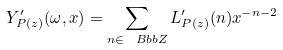<formula> <loc_0><loc_0><loc_500><loc_500>Y ^ { \prime } _ { P ( z ) } ( \omega , x ) = \sum _ { n \in { \ B b b Z } } L ^ { \prime } _ { P ( z ) } ( n ) x ^ { - n - 2 }</formula> 